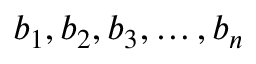Convert formula to latex. <formula><loc_0><loc_0><loc_500><loc_500>b _ { 1 } , b _ { 2 } , b _ { 3 } , \dots , b _ { n }</formula> 